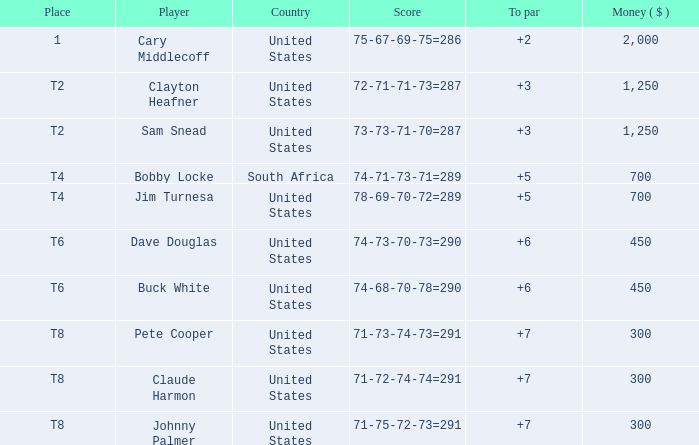What is the johnny palmer with a to more than 6 money amount? 300.0. 